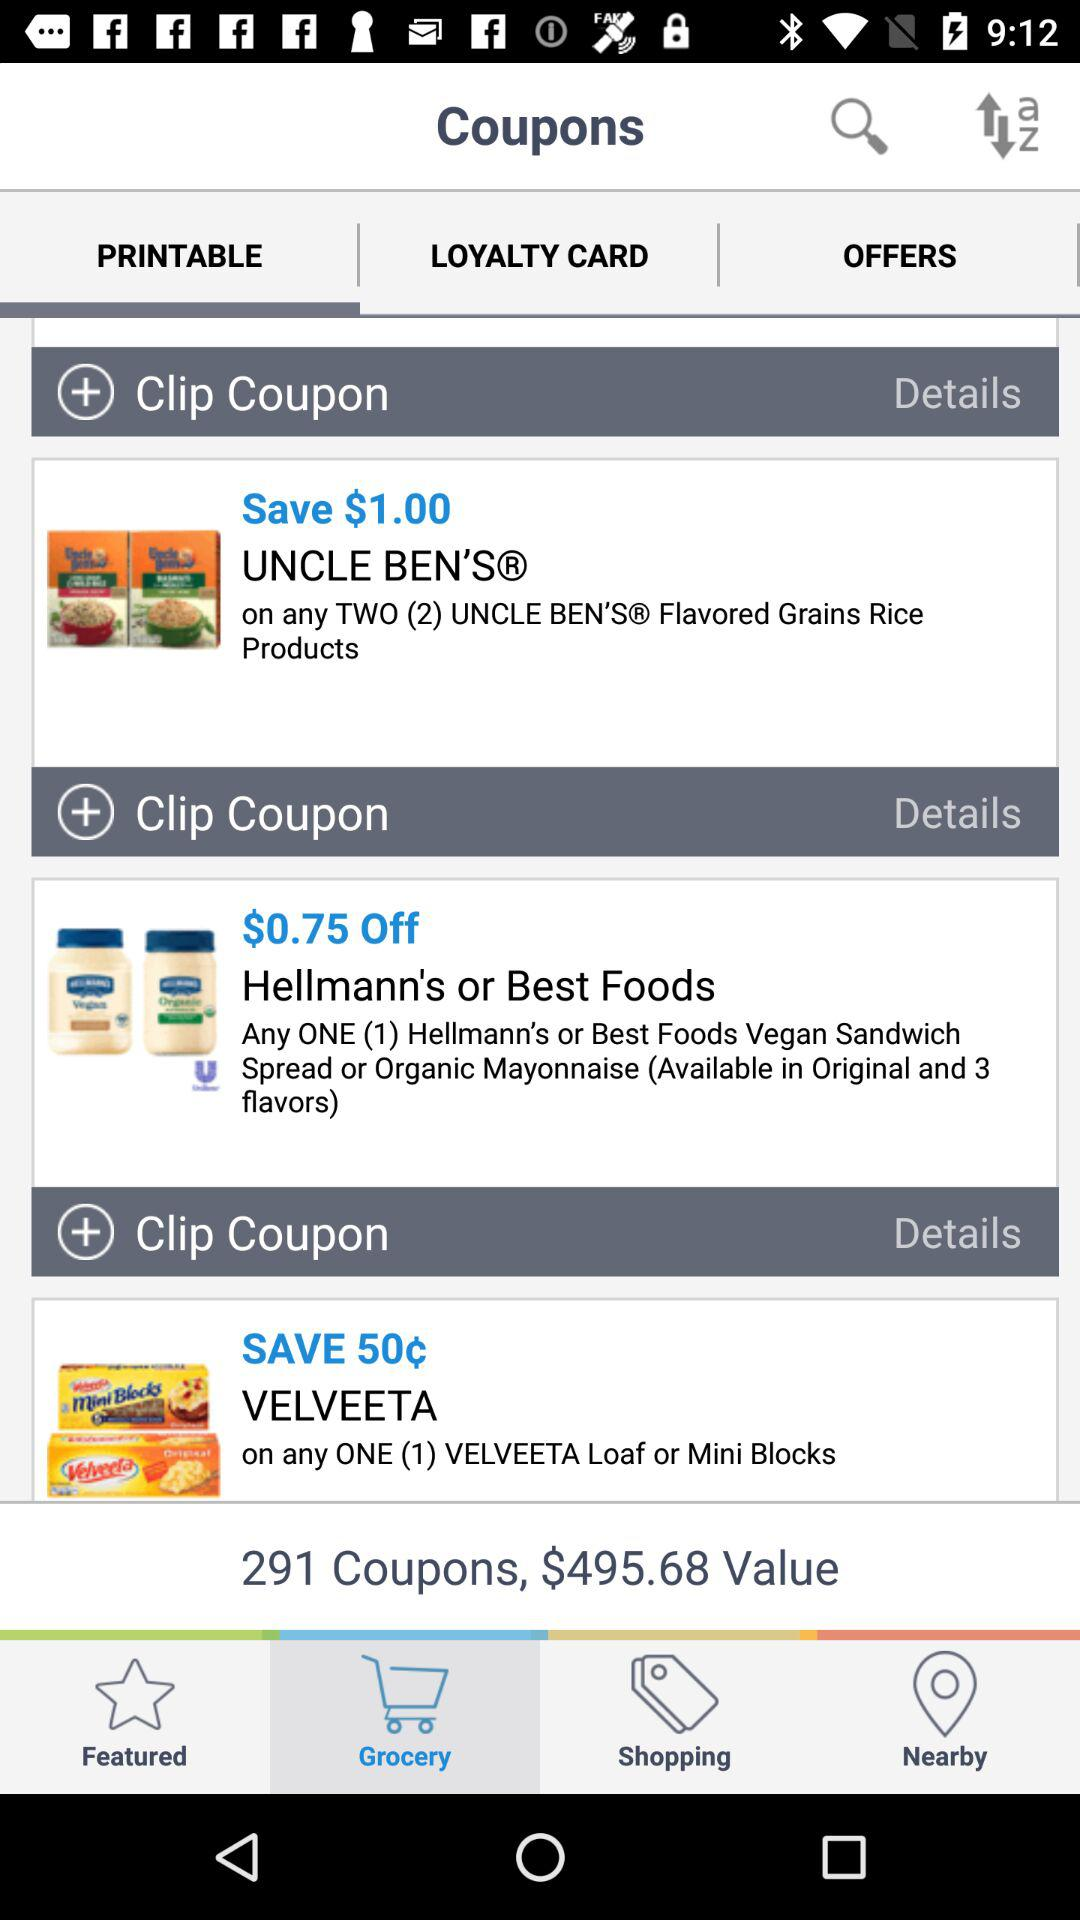How much money can be saved on "UNCLE BEN'S" products? On "UNCLE BEN'S" products, $1 can be saved. 